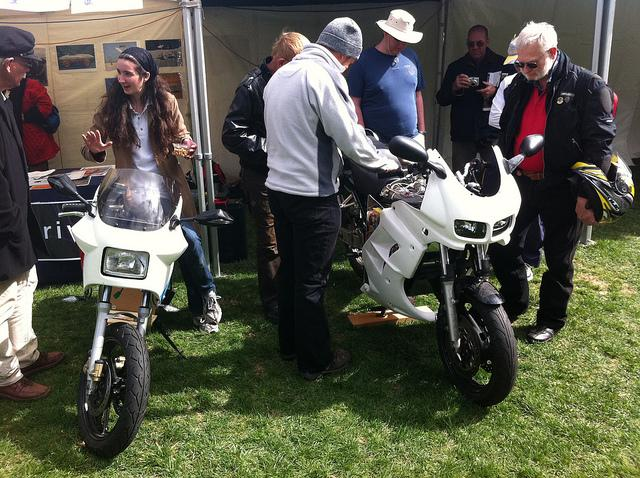What animal is the same color as the bike? Please explain your reasoning. swan. A swan is the same color as the white on the bikes. 